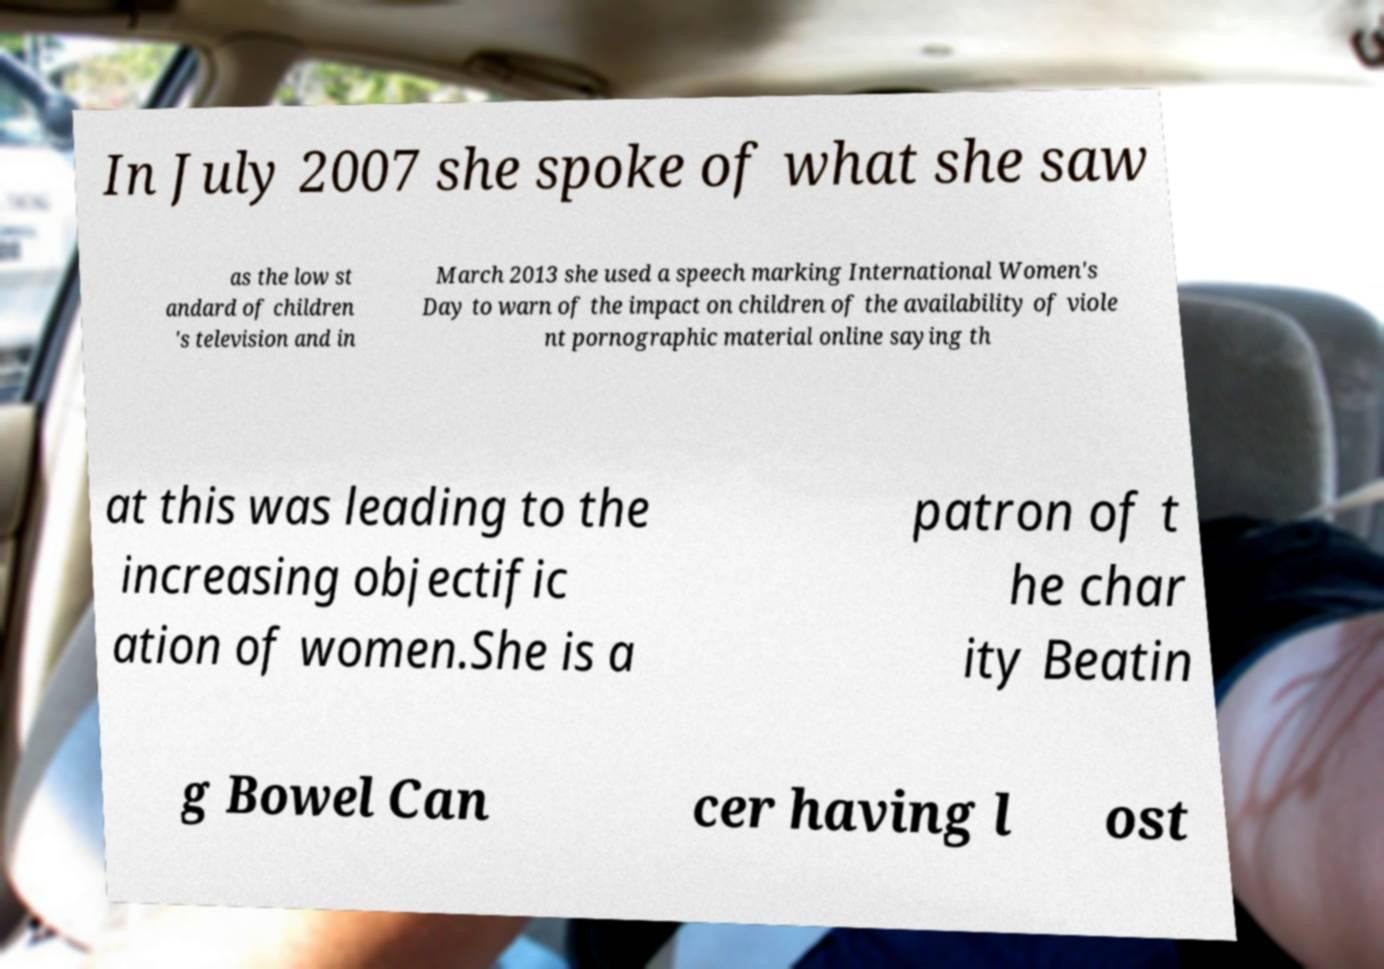For documentation purposes, I need the text within this image transcribed. Could you provide that? In July 2007 she spoke of what she saw as the low st andard of children 's television and in March 2013 she used a speech marking International Women's Day to warn of the impact on children of the availability of viole nt pornographic material online saying th at this was leading to the increasing objectific ation of women.She is a patron of t he char ity Beatin g Bowel Can cer having l ost 